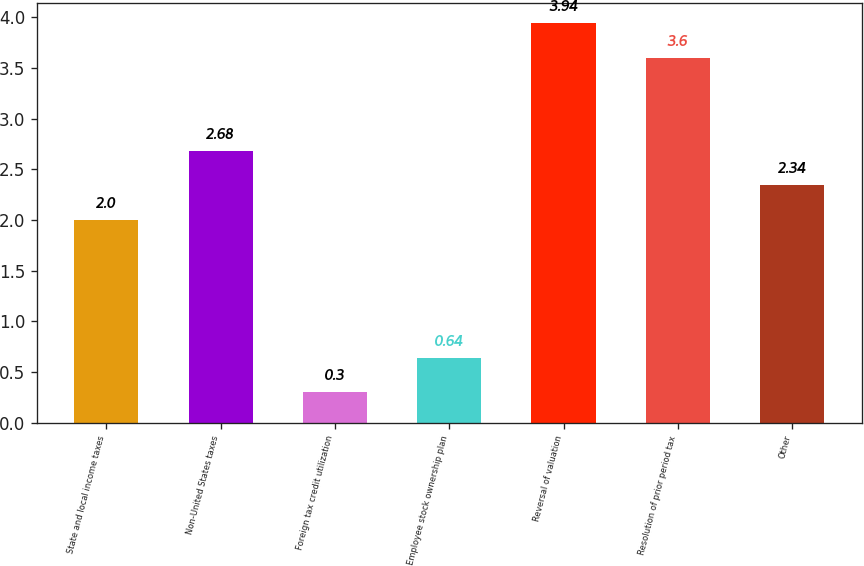Convert chart. <chart><loc_0><loc_0><loc_500><loc_500><bar_chart><fcel>State and local income taxes<fcel>Non-United States taxes<fcel>Foreign tax credit utilization<fcel>Employee stock ownership plan<fcel>Reversal of valuation<fcel>Resolution of prior period tax<fcel>Other<nl><fcel>2<fcel>2.68<fcel>0.3<fcel>0.64<fcel>3.94<fcel>3.6<fcel>2.34<nl></chart> 